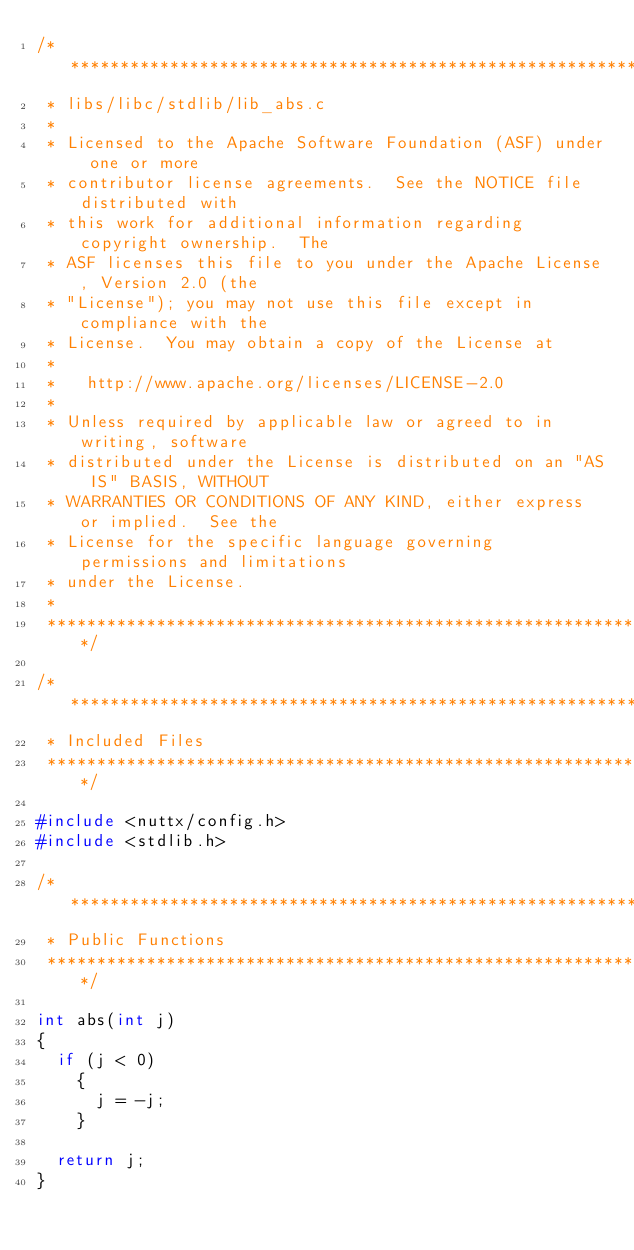Convert code to text. <code><loc_0><loc_0><loc_500><loc_500><_C_>/****************************************************************************
 * libs/libc/stdlib/lib_abs.c
 *
 * Licensed to the Apache Software Foundation (ASF) under one or more
 * contributor license agreements.  See the NOTICE file distributed with
 * this work for additional information regarding copyright ownership.  The
 * ASF licenses this file to you under the Apache License, Version 2.0 (the
 * "License"); you may not use this file except in compliance with the
 * License.  You may obtain a copy of the License at
 *
 *   http://www.apache.org/licenses/LICENSE-2.0
 *
 * Unless required by applicable law or agreed to in writing, software
 * distributed under the License is distributed on an "AS IS" BASIS, WITHOUT
 * WARRANTIES OR CONDITIONS OF ANY KIND, either express or implied.  See the
 * License for the specific language governing permissions and limitations
 * under the License.
 *
 ****************************************************************************/

/****************************************************************************
 * Included Files
 ****************************************************************************/

#include <nuttx/config.h>
#include <stdlib.h>

/****************************************************************************
 * Public Functions
 ****************************************************************************/

int abs(int j)
{
  if (j < 0)
    {
      j = -j;
    }

  return j;
}
</code> 